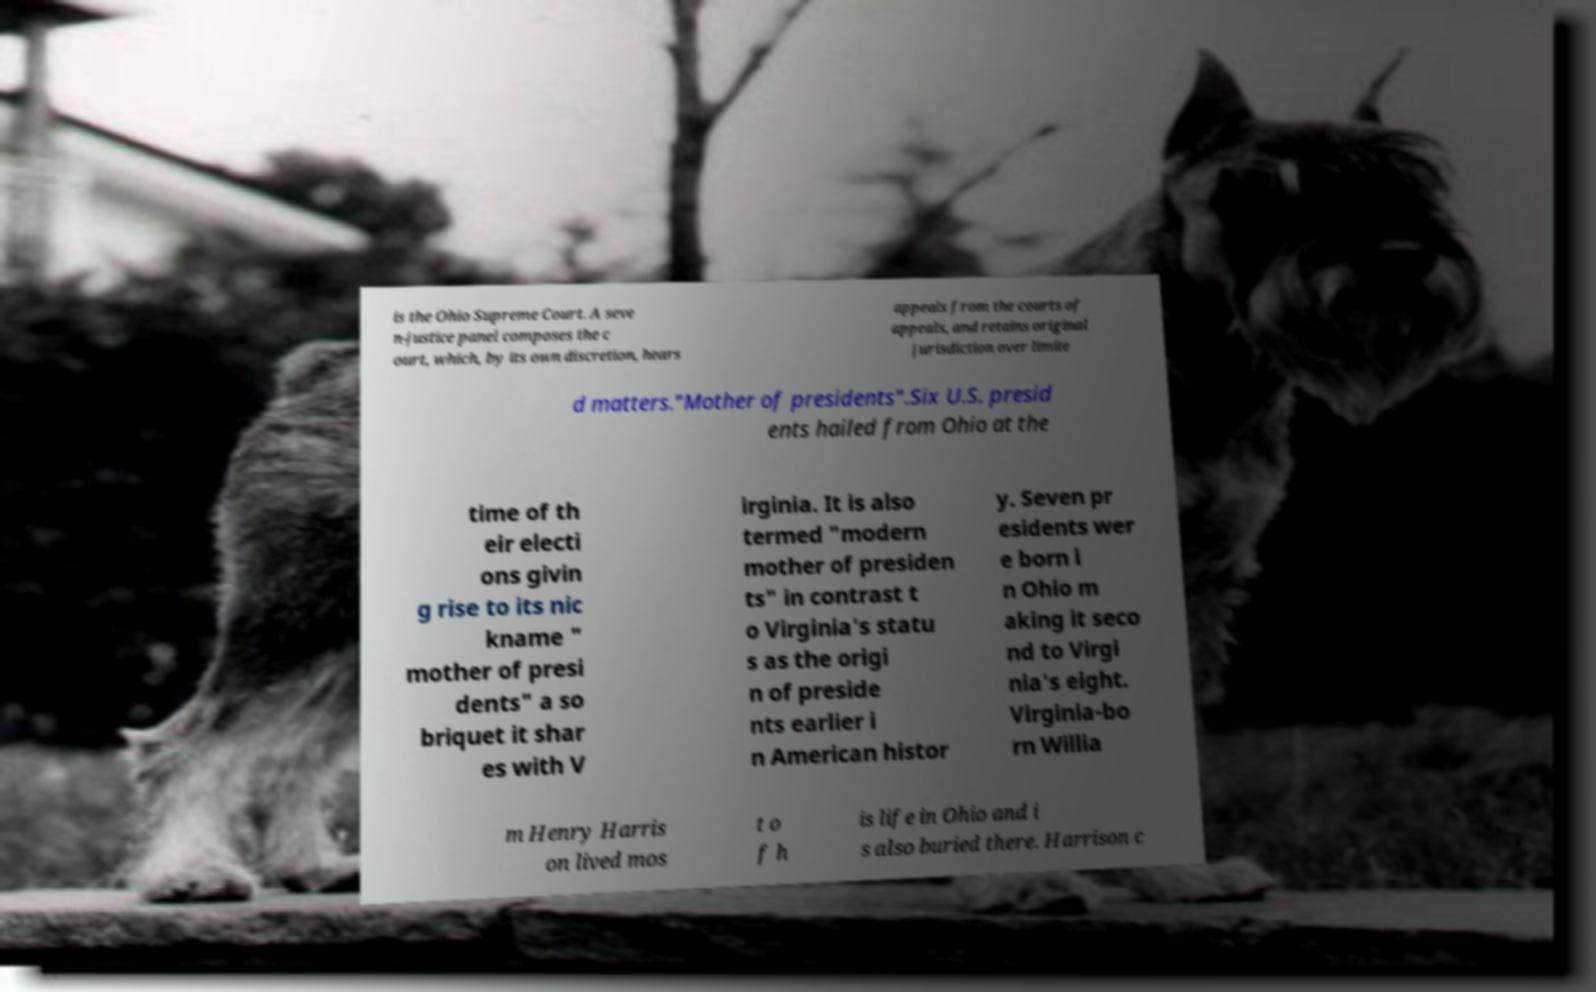What messages or text are displayed in this image? I need them in a readable, typed format. is the Ohio Supreme Court. A seve n-justice panel composes the c ourt, which, by its own discretion, hears appeals from the courts of appeals, and retains original jurisdiction over limite d matters."Mother of presidents".Six U.S. presid ents hailed from Ohio at the time of th eir electi ons givin g rise to its nic kname " mother of presi dents" a so briquet it shar es with V irginia. It is also termed "modern mother of presiden ts" in contrast t o Virginia's statu s as the origi n of preside nts earlier i n American histor y. Seven pr esidents wer e born i n Ohio m aking it seco nd to Virgi nia's eight. Virginia-bo rn Willia m Henry Harris on lived mos t o f h is life in Ohio and i s also buried there. Harrison c 